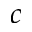Convert formula to latex. <formula><loc_0><loc_0><loc_500><loc_500>c</formula> 